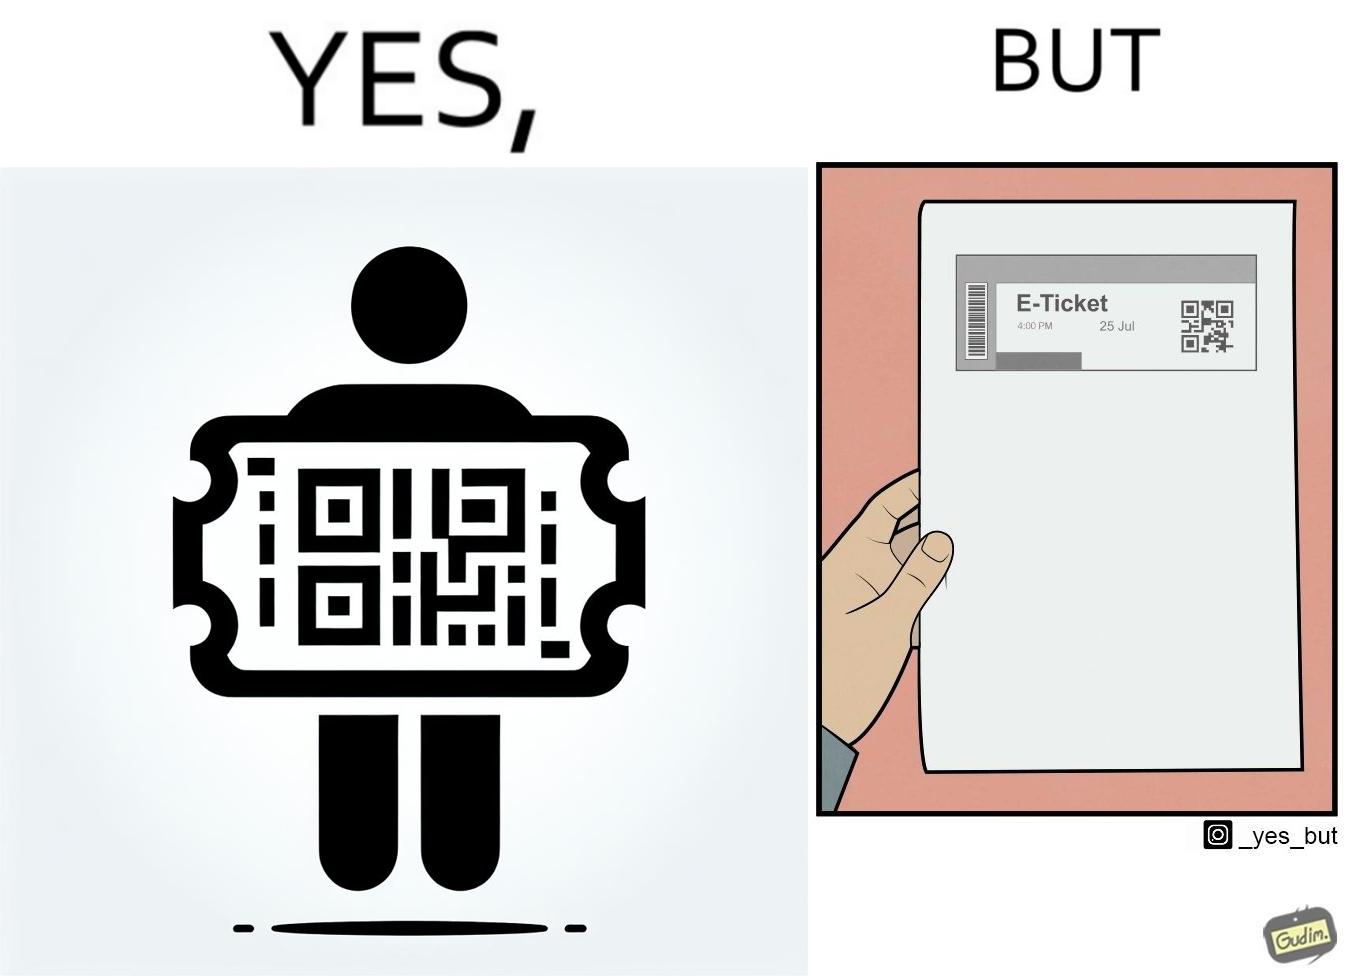Describe the contrast between the left and right parts of this image. In the left part of the image: It is an e-ticket In the right part of the image: It is an e-ticket printed on paper 